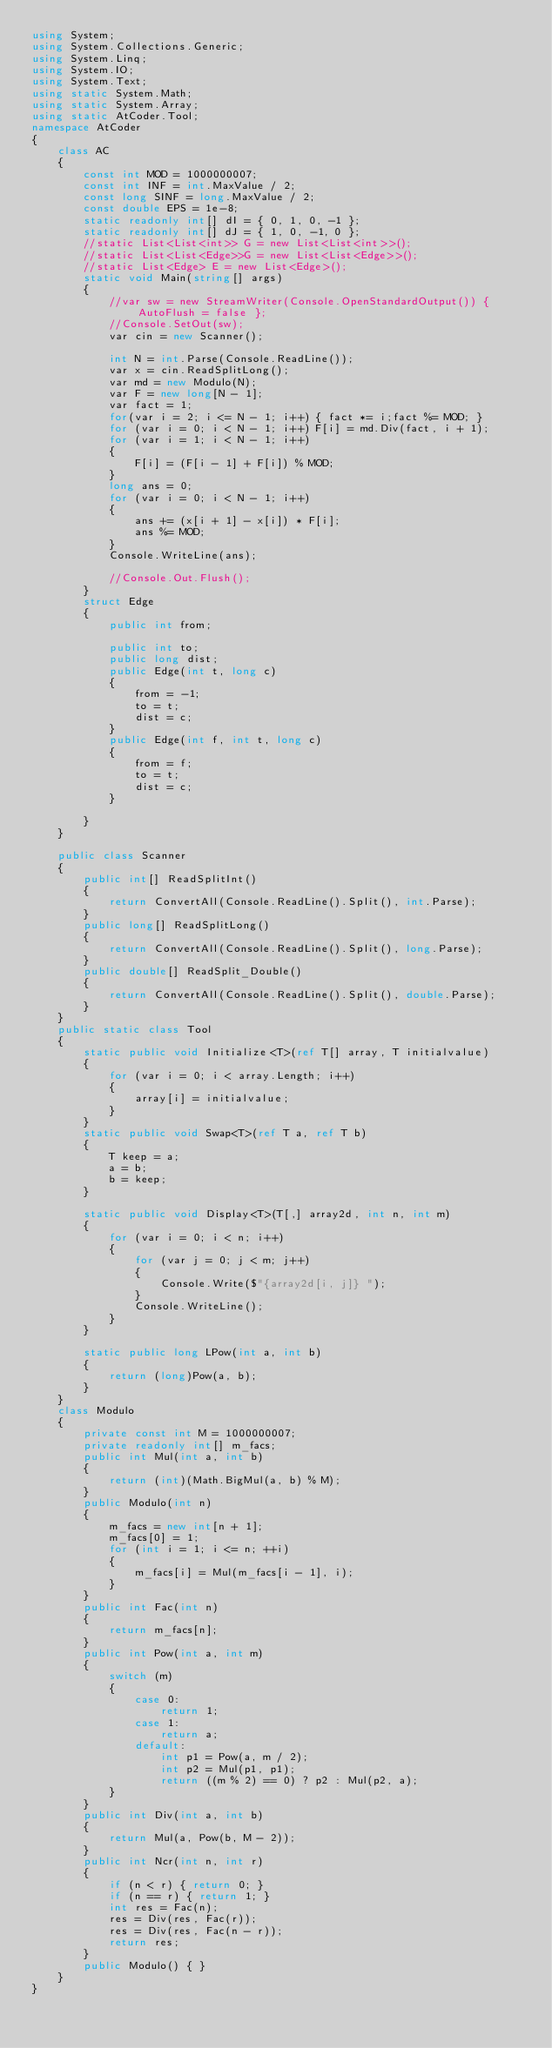<code> <loc_0><loc_0><loc_500><loc_500><_C#_>using System;
using System.Collections.Generic;
using System.Linq;
using System.IO;
using System.Text;
using static System.Math;
using static System.Array;
using static AtCoder.Tool;
namespace AtCoder
{
    class AC
    {
        const int MOD = 1000000007;
        const int INF = int.MaxValue / 2;
        const long SINF = long.MaxValue / 2;
        const double EPS = 1e-8;
        static readonly int[] dI = { 0, 1, 0, -1 };
        static readonly int[] dJ = { 1, 0, -1, 0 };
        //static List<List<int>> G = new List<List<int>>();
        //static List<List<Edge>>G = new List<List<Edge>>();
        //static List<Edge> E = new List<Edge>();
        static void Main(string[] args)
        {
            //var sw = new StreamWriter(Console.OpenStandardOutput()) { AutoFlush = false };
            //Console.SetOut(sw);
            var cin = new Scanner();

            int N = int.Parse(Console.ReadLine());
            var x = cin.ReadSplitLong();
            var md = new Modulo(N);
            var F = new long[N - 1];
            var fact = 1;
            for(var i = 2; i <= N - 1; i++) { fact *= i;fact %= MOD; }
            for (var i = 0; i < N - 1; i++) F[i] = md.Div(fact, i + 1);
            for (var i = 1; i < N - 1; i++)
            {
                F[i] = (F[i - 1] + F[i]) % MOD;
            }
            long ans = 0;
            for (var i = 0; i < N - 1; i++)
            {
                ans += (x[i + 1] - x[i]) * F[i];
                ans %= MOD;
            }
            Console.WriteLine(ans);

            //Console.Out.Flush();
        }
        struct Edge
        {
            public int from;

            public int to;
            public long dist;
            public Edge(int t, long c)
            {
                from = -1;
                to = t;
                dist = c;
            }
            public Edge(int f, int t, long c)
            {
                from = f;
                to = t;
                dist = c;
            }

        }
    }
    
    public class Scanner
    {
        public int[] ReadSplitInt()
        {
            return ConvertAll(Console.ReadLine().Split(), int.Parse);
        }
        public long[] ReadSplitLong()
        {
            return ConvertAll(Console.ReadLine().Split(), long.Parse);
        }
        public double[] ReadSplit_Double()
        {
            return ConvertAll(Console.ReadLine().Split(), double.Parse);
        }
    }
    public static class Tool
    {
        static public void Initialize<T>(ref T[] array, T initialvalue)
        {
            for (var i = 0; i < array.Length; i++)
            {
                array[i] = initialvalue;
            }
        }
        static public void Swap<T>(ref T a, ref T b)
        {
            T keep = a;
            a = b;
            b = keep;
        }

        static public void Display<T>(T[,] array2d, int n, int m)
        {
            for (var i = 0; i < n; i++)
            {
                for (var j = 0; j < m; j++)
                {
                    Console.Write($"{array2d[i, j]} ");
                }
                Console.WriteLine();
            }
        }

        static public long LPow(int a, int b)
        {
            return (long)Pow(a, b);
        }
    }
    class Modulo
    {
        private const int M = 1000000007;
        private readonly int[] m_facs;
        public int Mul(int a, int b)
        {
            return (int)(Math.BigMul(a, b) % M);
        }
        public Modulo(int n)
        {
            m_facs = new int[n + 1];
            m_facs[0] = 1;
            for (int i = 1; i <= n; ++i)
            {
                m_facs[i] = Mul(m_facs[i - 1], i);
            }
        }
        public int Fac(int n)
        {
            return m_facs[n];
        }
        public int Pow(int a, int m)
        {
            switch (m)
            {
                case 0:
                    return 1;
                case 1:
                    return a;
                default:
                    int p1 = Pow(a, m / 2);
                    int p2 = Mul(p1, p1);
                    return ((m % 2) == 0) ? p2 : Mul(p2, a);
            }
        }
        public int Div(int a, int b)
        {
            return Mul(a, Pow(b, M - 2));
        }
        public int Ncr(int n, int r)
        {
            if (n < r) { return 0; }
            if (n == r) { return 1; }
            int res = Fac(n);
            res = Div(res, Fac(r));
            res = Div(res, Fac(n - r));
            return res;
        }
        public Modulo() { }
    }
}
</code> 